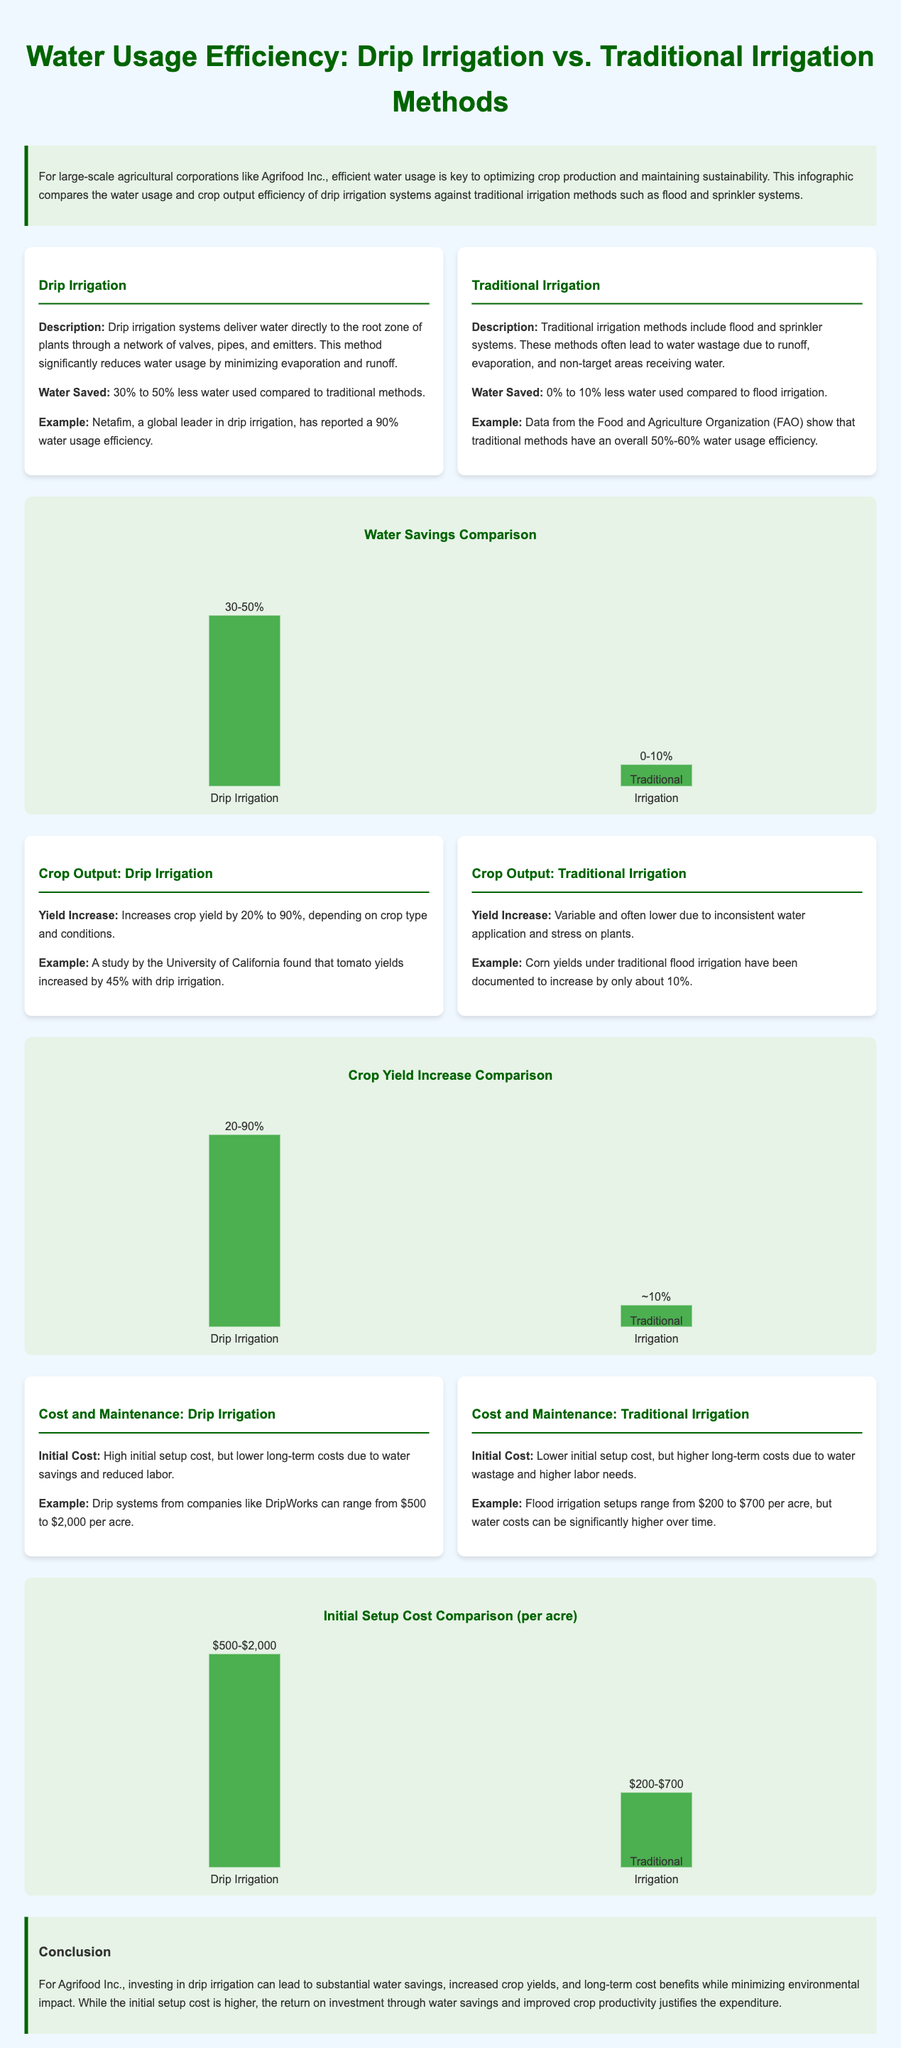What is the water savings percentage for drip irrigation? The document states that drip irrigation systems save 30% to 50% less water compared to traditional methods.
Answer: 30% to 50% What is the yield increase range for drip irrigation? It mentions that drip irrigation can increase crop yield by 20% to 90% depending on conditions and crop type.
Answer: 20% to 90% What is the initial cost range of drip irrigation per acre? The initial cost for drip irrigation systems ranges from $500 to $2,000 per acre.
Answer: $500-$2,000 What is the water usage efficiency percentage for traditional irrigation methods? The document indicates that traditional irrigation methods have an overall 50%-60% water usage efficiency according to FAO data.
Answer: 50%-60% Which irrigation method is more efficient in terms of water savings? The comparison shows that drip irrigation uses significantly less water compared to traditional irrigation methods.
Answer: Drip irrigation What is the yield increase percentage mentioned for corn under traditional irrigation? It states that corn yields under traditional flood irrigation have been documented to increase by only about 10%.
Answer: ~10% Which irrigation method has lower long-term costs due to water savings? The analysis in the document describes that drip irrigation has lower long-term costs due to its efficiency in water usage.
Answer: Drip irrigation What type of infographic is presented in the document? The document is a comparison infographic illustrating water usage efficiency between drip and traditional irrigation methods.
Answer: Comparison infographic What is the percentage of water saved by traditional irrigation according to the document? The document specifies that traditional irrigation saves only 0% to 10% less water compared to flood irrigation.
Answer: 0% to 10% 